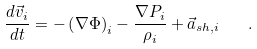Convert formula to latex. <formula><loc_0><loc_0><loc_500><loc_500>\frac { d \vec { v } _ { i } } { d t } = - \left ( \nabla \Phi \right ) _ { i } - \frac { \nabla P _ { i } } { \rho _ { i } } + \vec { a } _ { s h , i } \quad .</formula> 